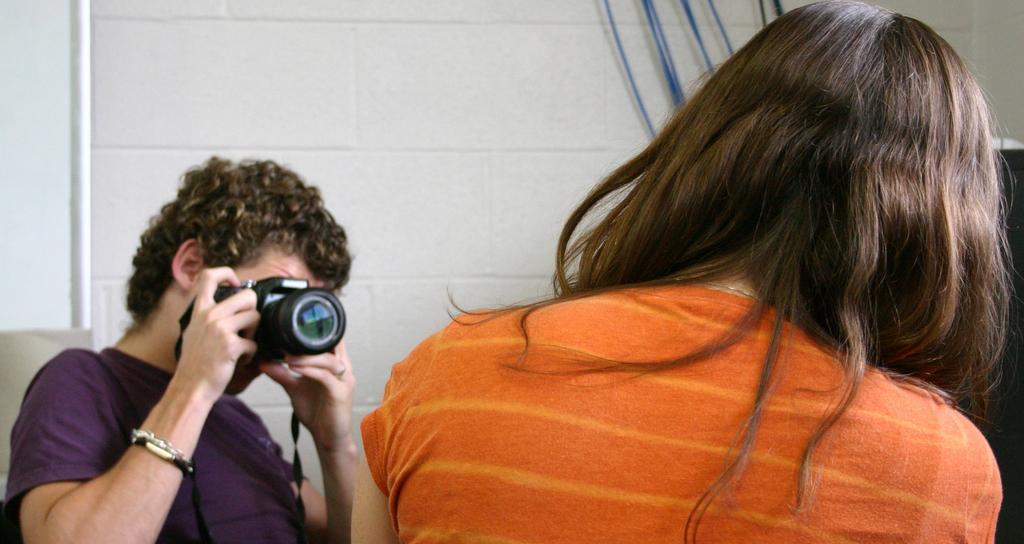Describe this image in one or two sentences. In the image there are two people. The man sitting on the left is holding a camera in his hand and clicking a pic. On the right there is a lady sitting. In the background there is a wall. 